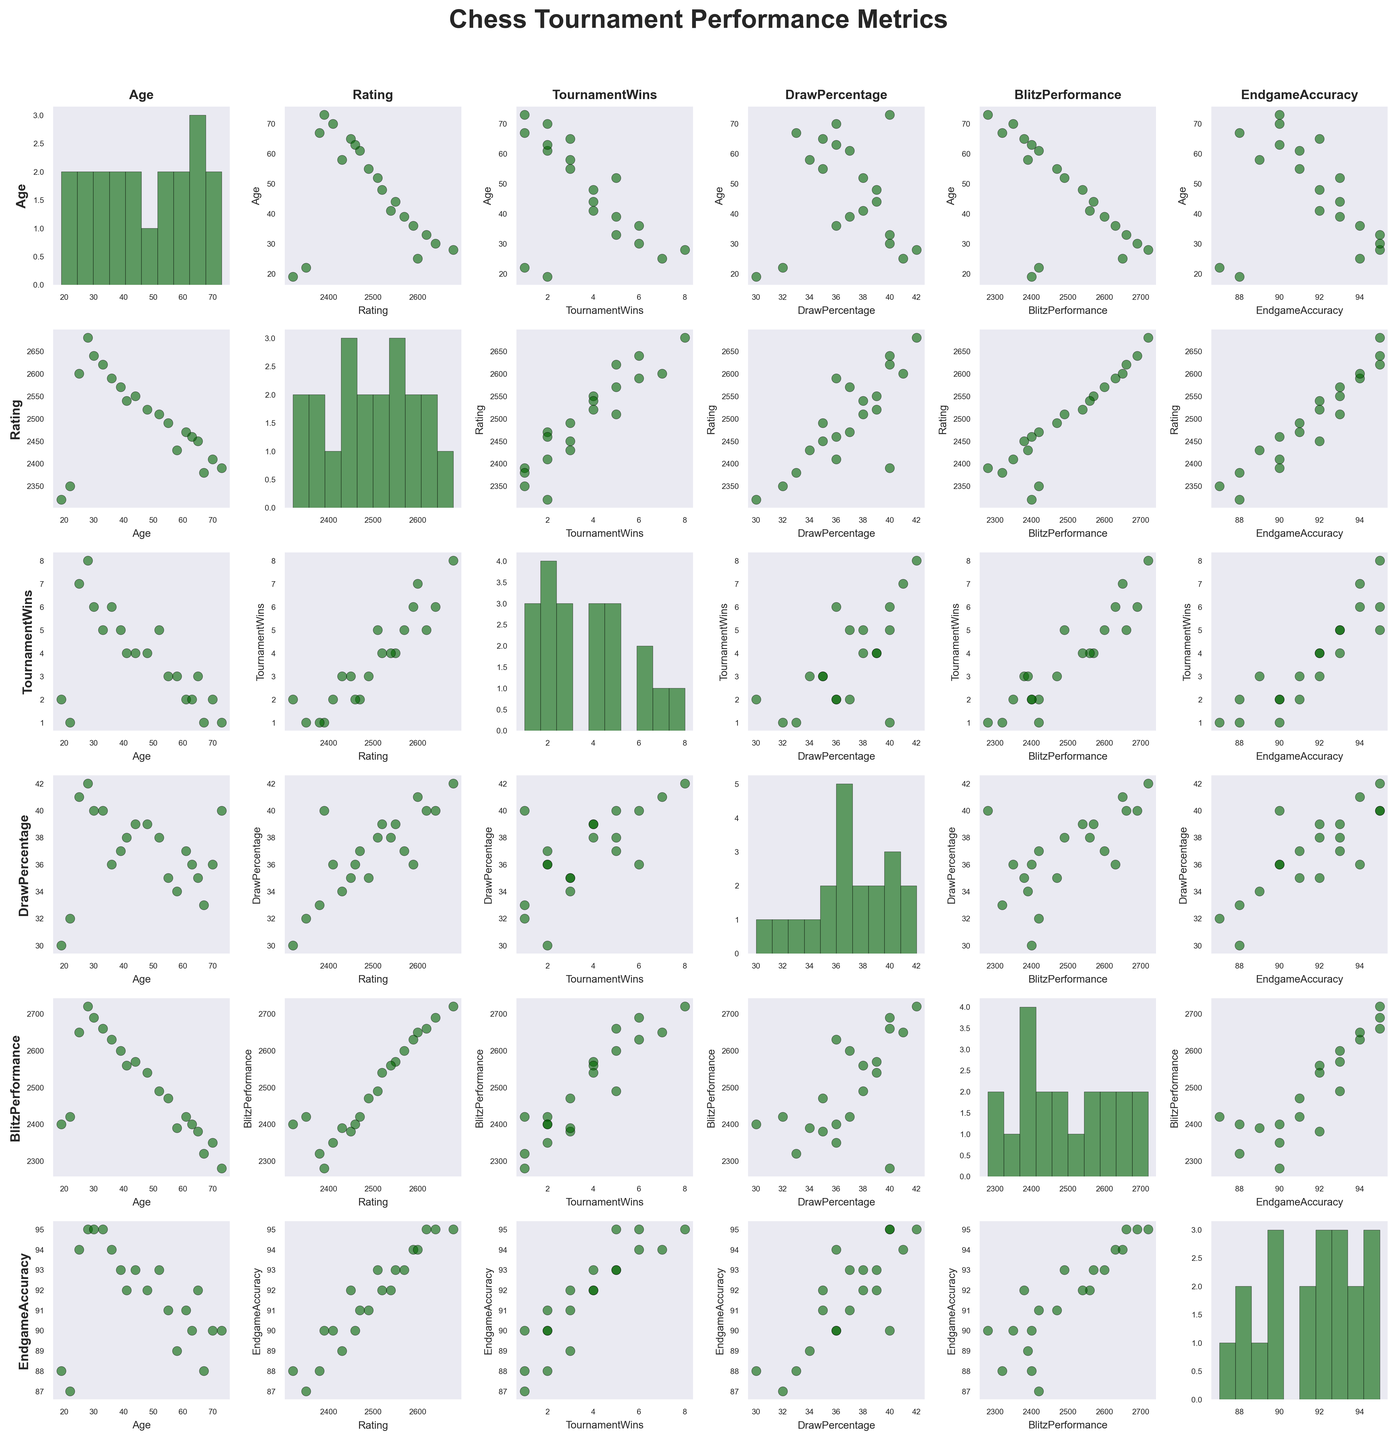What is the title of the figure? The title is visible at the top center of the figure, stating the main purpose of the figure. It is written in a large, bold font.
Answer: "Chess Tournament Performance Metrics" How many variables are plotted in the scatterplot matrix? Each variable corresponds to a row and a column in the scatterplot matrix. Count all the unique axis labels.
Answer: 6 Which age group has the highest player rating? Look at the scatter plots related to the 'Age' and 'Rating' axes and identify the age corresponding to the highest rating value.
Answer: 28 What is the average Tournament Wins for players younger than 30? Identify all data points where Age is less than 30, sum the Tournament Wins for these points, and then divide by the number of such data points.
Answer: (2 + 7 + 8 + 1) / 4 = 4.5 How does the variability in Blitz Performance compare between older (60+) and younger (below 30) players? Examine the range and spread of data in the Blitz Performance plots for both age groups. Compare the scatters' width in the vertical or horizontal direction corresponding to these age ranges.
Answer: Older: more variable; Younger: less variable Is there a visible correlation between Rating and Tournament Wins? Observe the scatter plot where Rating is on one axis and Tournament Wins is on the other, and look for any trend or pattern.
Answer: Positive correlation Do players with higher Endgame Accuracy generally have a higher Blitz Performance? Compare data points from the scatter plot of Blitz Performance vs. Endgame Accuracy and observe if there's an upward trend.
Answer: Yes What is the distribution of Age among chess players? Refer to the histogram on the diagonal where Age is plotted against itself. Analyze the spread and common age values of data points.
Answer: Bimodal, peaks around 25 and 65 Can you find a relationship between Draw Percentage and Tournament Wins? Look at the scatter plot where Draw Percentage and Tournament Wins intersect, and determine if there is any visible trend.
Answer: No clear relationship Which variable shows the least variability in its histogram? Examine the histograms on the diagonal and identify which one has the narrowest spread or tightest clustering of data points.
Answer: Endgame Accuracy 